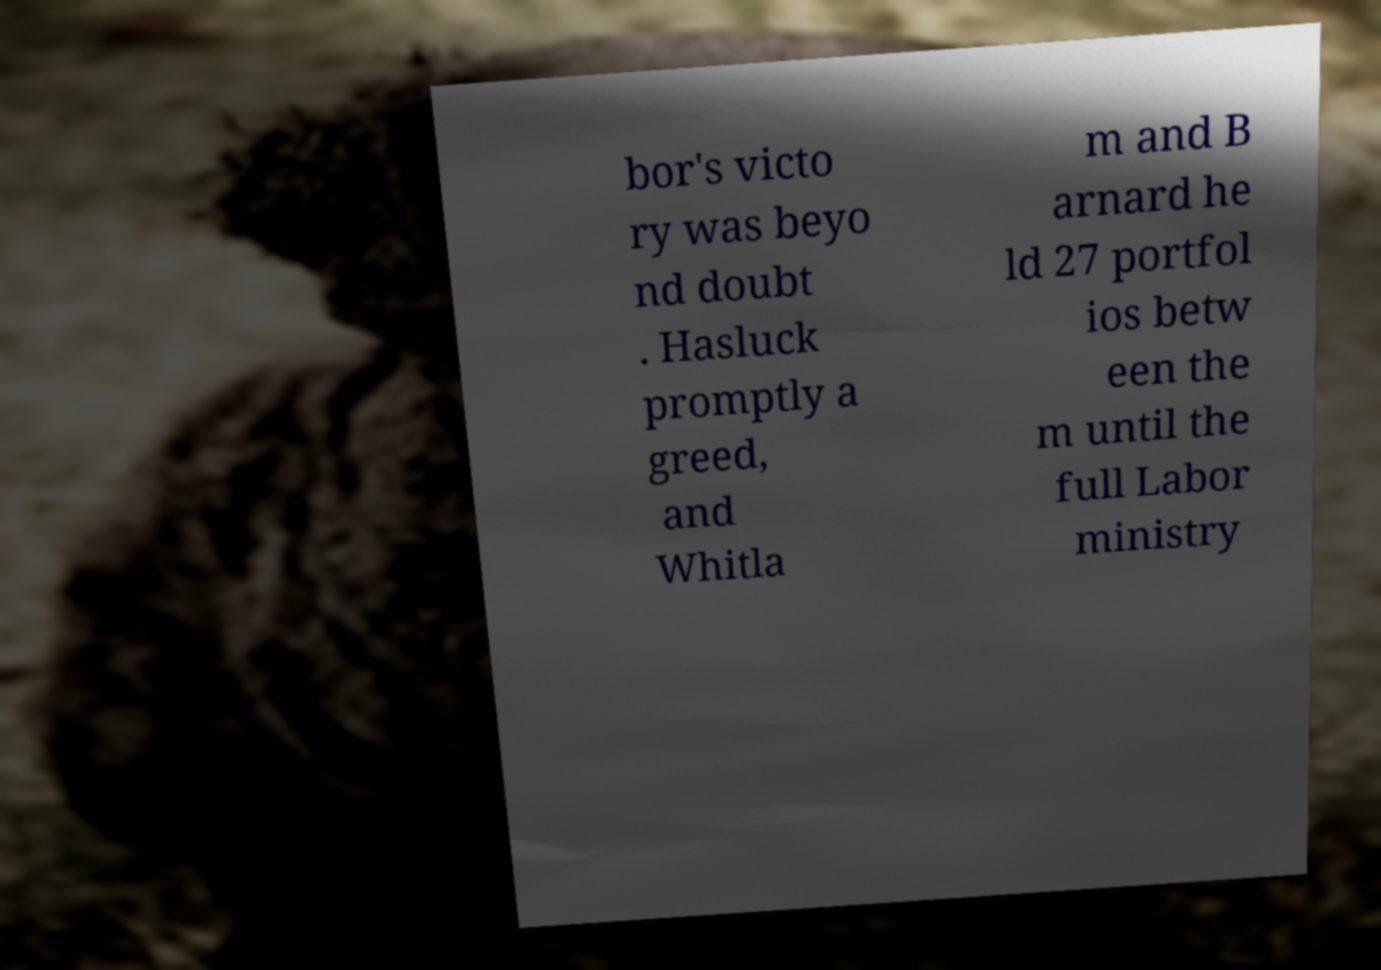What messages or text are displayed in this image? I need them in a readable, typed format. bor's victo ry was beyo nd doubt . Hasluck promptly a greed, and Whitla m and B arnard he ld 27 portfol ios betw een the m until the full Labor ministry 